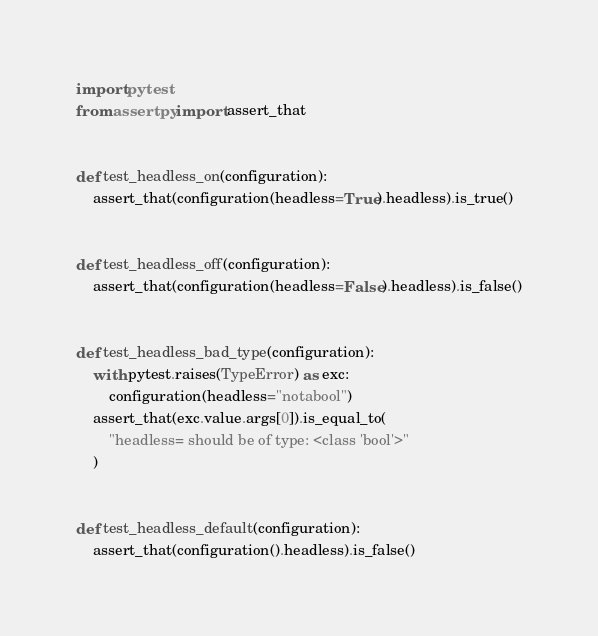<code> <loc_0><loc_0><loc_500><loc_500><_Python_>import pytest
from assertpy import assert_that


def test_headless_on(configuration):
    assert_that(configuration(headless=True).headless).is_true()


def test_headless_off(configuration):
    assert_that(configuration(headless=False).headless).is_false()


def test_headless_bad_type(configuration):
    with pytest.raises(TypeError) as exc:
        configuration(headless="notabool")
    assert_that(exc.value.args[0]).is_equal_to(
        "headless= should be of type: <class 'bool'>"
    )


def test_headless_default(configuration):
    assert_that(configuration().headless).is_false()
</code> 